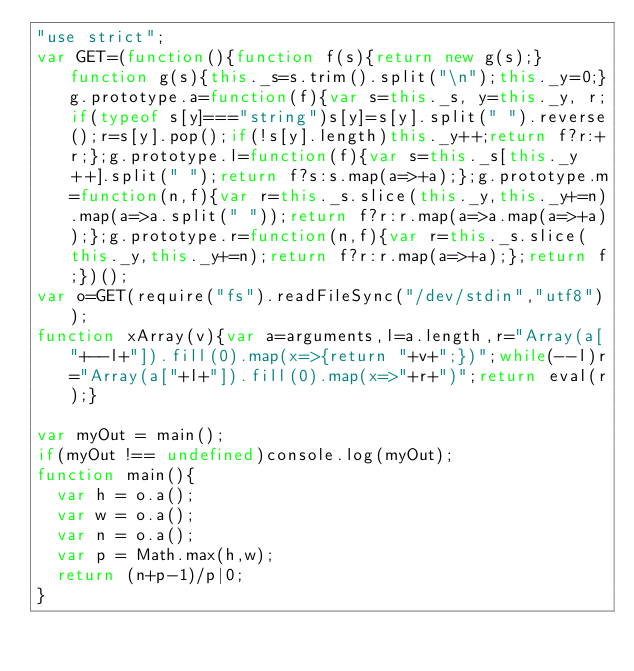<code> <loc_0><loc_0><loc_500><loc_500><_JavaScript_>"use strict";
var GET=(function(){function f(s){return new g(s);}function g(s){this._s=s.trim().split("\n");this._y=0;}g.prototype.a=function(f){var s=this._s, y=this._y, r;if(typeof s[y]==="string")s[y]=s[y].split(" ").reverse();r=s[y].pop();if(!s[y].length)this._y++;return f?r:+r;};g.prototype.l=function(f){var s=this._s[this._y++].split(" ");return f?s:s.map(a=>+a);};g.prototype.m=function(n,f){var r=this._s.slice(this._y,this._y+=n).map(a=>a.split(" "));return f?r:r.map(a=>a.map(a=>+a));};g.prototype.r=function(n,f){var r=this._s.slice(this._y,this._y+=n);return f?r:r.map(a=>+a);};return f;})();
var o=GET(require("fs").readFileSync("/dev/stdin","utf8"));
function xArray(v){var a=arguments,l=a.length,r="Array(a["+--l+"]).fill(0).map(x=>{return "+v+";})";while(--l)r="Array(a["+l+"]).fill(0).map(x=>"+r+")";return eval(r);}

var myOut = main();
if(myOut !== undefined)console.log(myOut);
function main(){
  var h = o.a();
  var w = o.a();
  var n = o.a();
  var p = Math.max(h,w);
  return (n+p-1)/p|0;
}</code> 